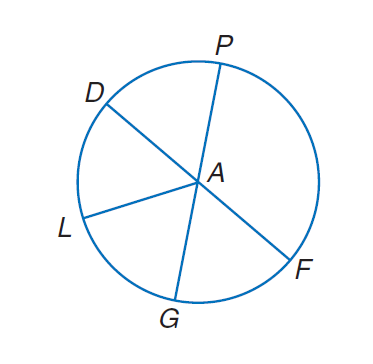Answer the mathemtical geometry problem and directly provide the correct option letter.
Question: Circle A has diameters D F and P G. If A G = 12, find L A.
Choices: A: 12 B: 24 C: 36 D: 48 A 